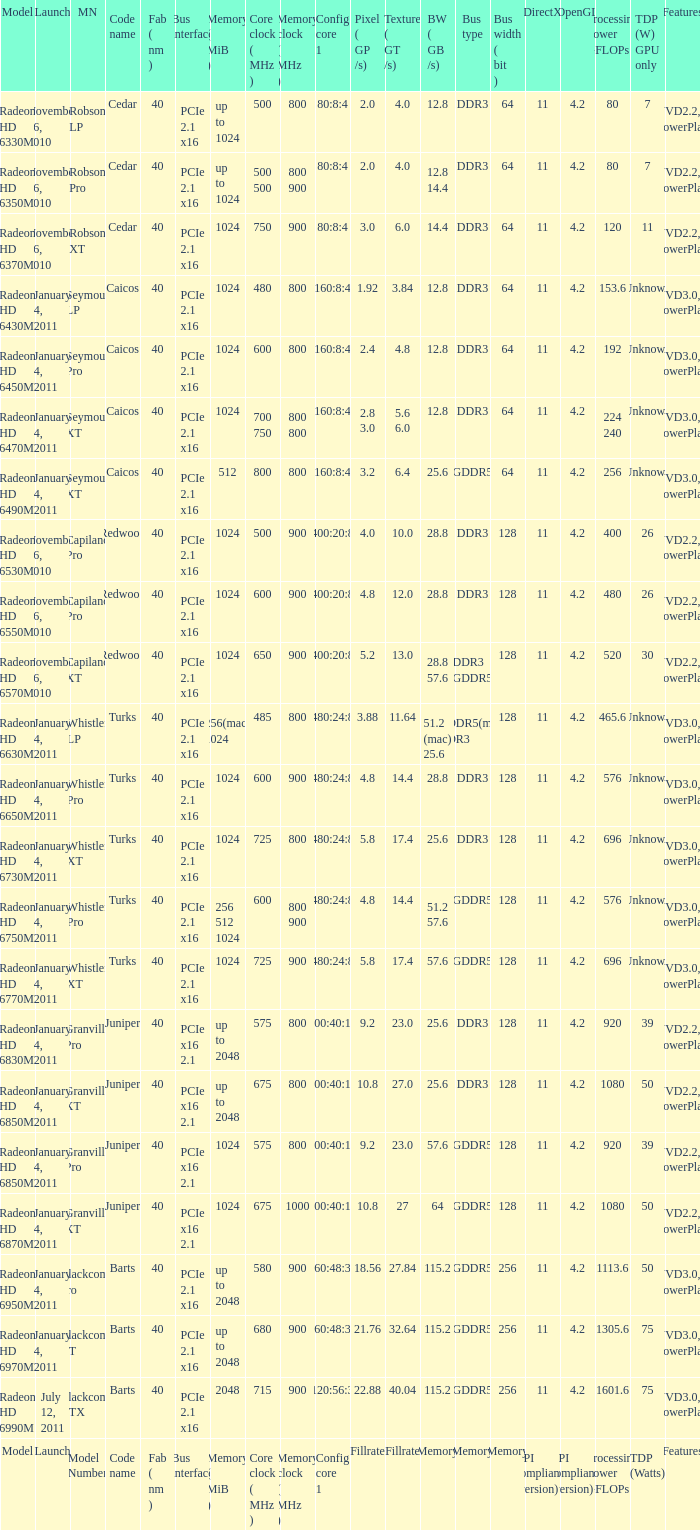How many values for fab(nm) if the model number is Whistler LP? 1.0. 